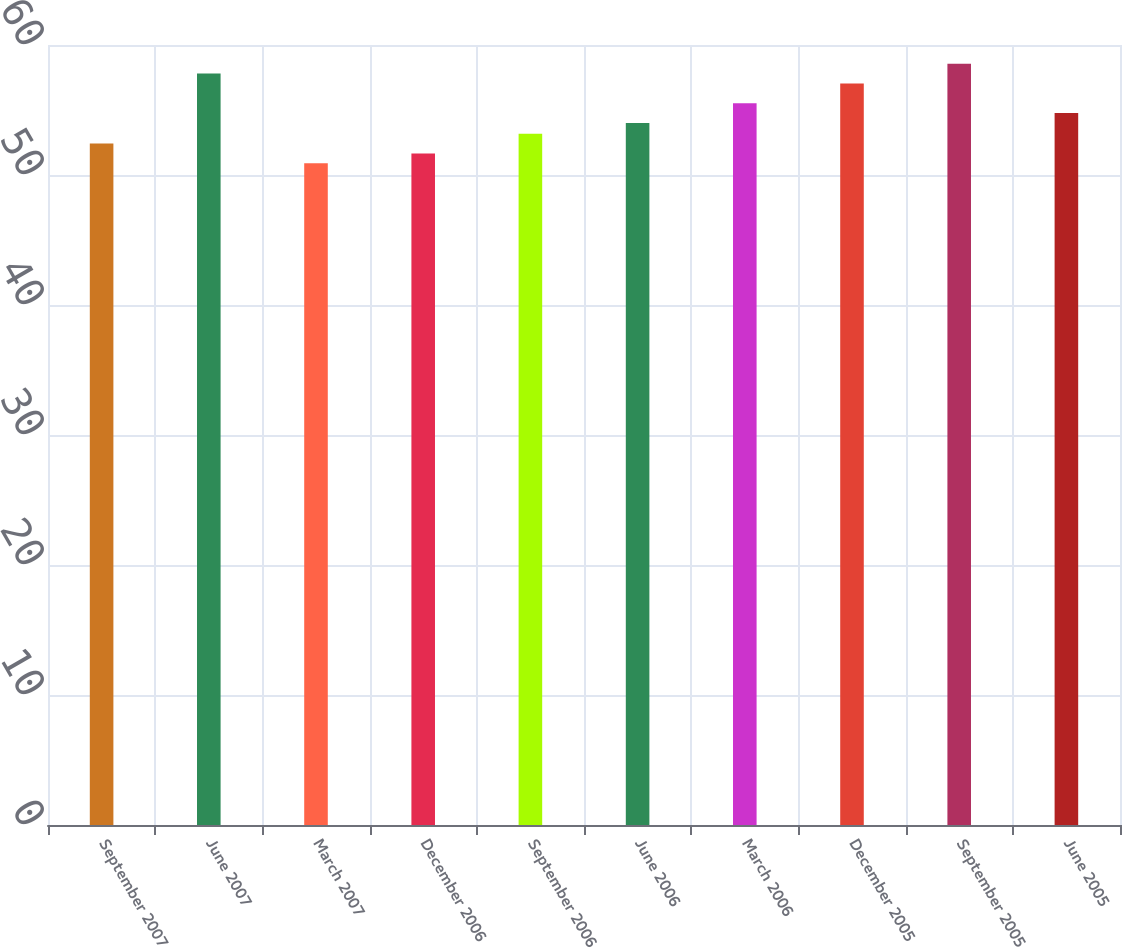<chart> <loc_0><loc_0><loc_500><loc_500><bar_chart><fcel>September 2007<fcel>June 2007<fcel>March 2007<fcel>December 2006<fcel>September 2006<fcel>June 2006<fcel>March 2006<fcel>December 2005<fcel>September 2005<fcel>June 2005<nl><fcel>52.42<fcel>57.8<fcel>50.9<fcel>51.66<fcel>53.18<fcel>54<fcel>55.52<fcel>57.04<fcel>58.56<fcel>54.76<nl></chart> 